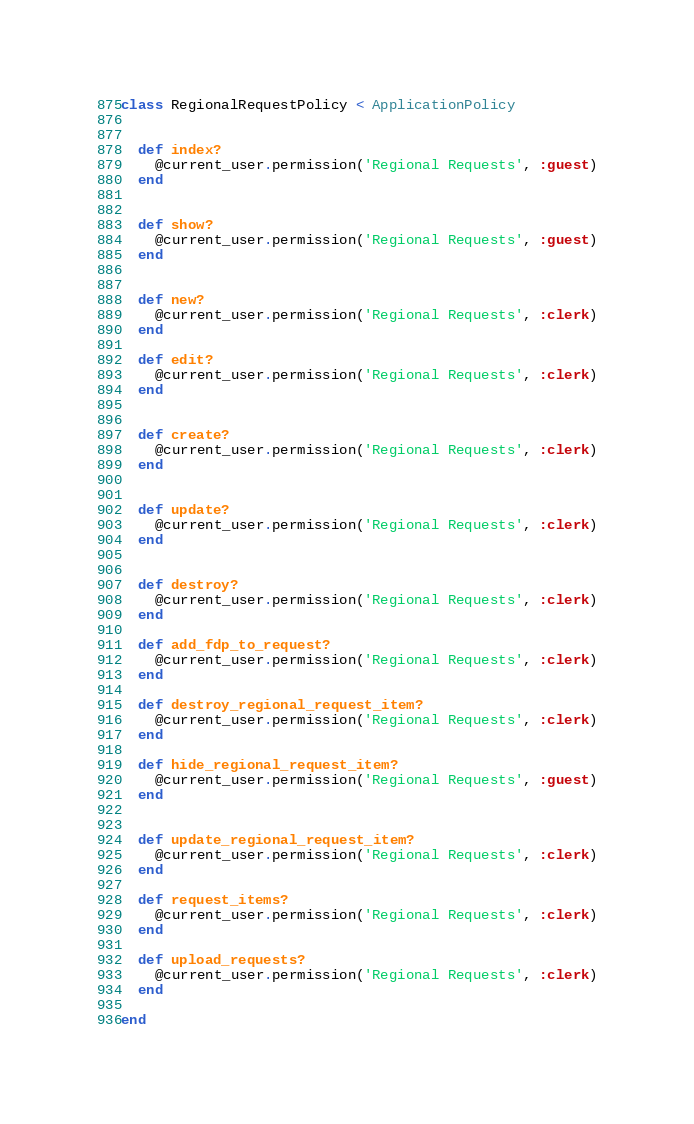<code> <loc_0><loc_0><loc_500><loc_500><_Ruby_>class RegionalRequestPolicy < ApplicationPolicy


  def index?
    @current_user.permission('Regional Requests', :guest)
  end


  def show?
    @current_user.permission('Regional Requests', :guest)
  end

  
  def new?
    @current_user.permission('Regional Requests', :clerk)
  end

  def edit?
    @current_user.permission('Regional Requests', :clerk)
  end

 
  def create?
    @current_user.permission('Regional Requests', :clerk)
  end

 
  def update?
    @current_user.permission('Regional Requests', :clerk)
  end

 
  def destroy?
    @current_user.permission('Regional Requests', :clerk)
  end

  def add_fdp_to_request?
    @current_user.permission('Regional Requests', :clerk)
  end
  
  def destroy_regional_request_item?
    @current_user.permission('Regional Requests', :clerk)
  end

  def hide_regional_request_item?
    @current_user.permission('Regional Requests', :guest)
  end
  

  def update_regional_request_item?
    @current_user.permission('Regional Requests', :clerk)
  end

  def request_items?
    @current_user.permission('Regional Requests', :clerk)
  end

  def upload_requests?
    @current_user.permission('Regional Requests', :clerk)
  end 
  
end

</code> 